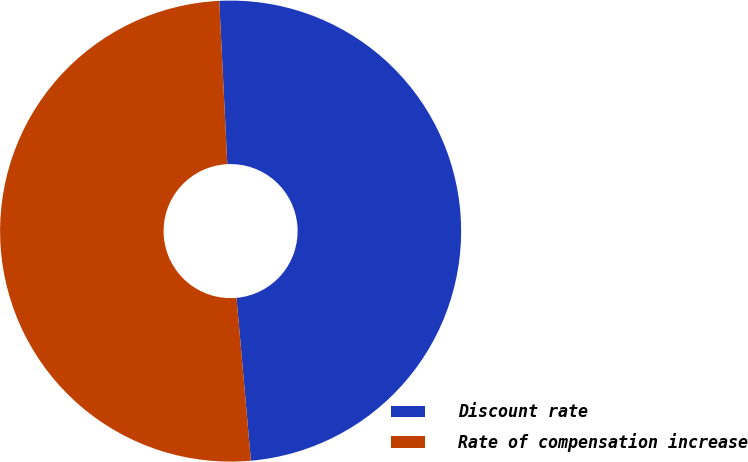<chart> <loc_0><loc_0><loc_500><loc_500><pie_chart><fcel>Discount rate<fcel>Rate of compensation increase<nl><fcel>49.38%<fcel>50.62%<nl></chart> 